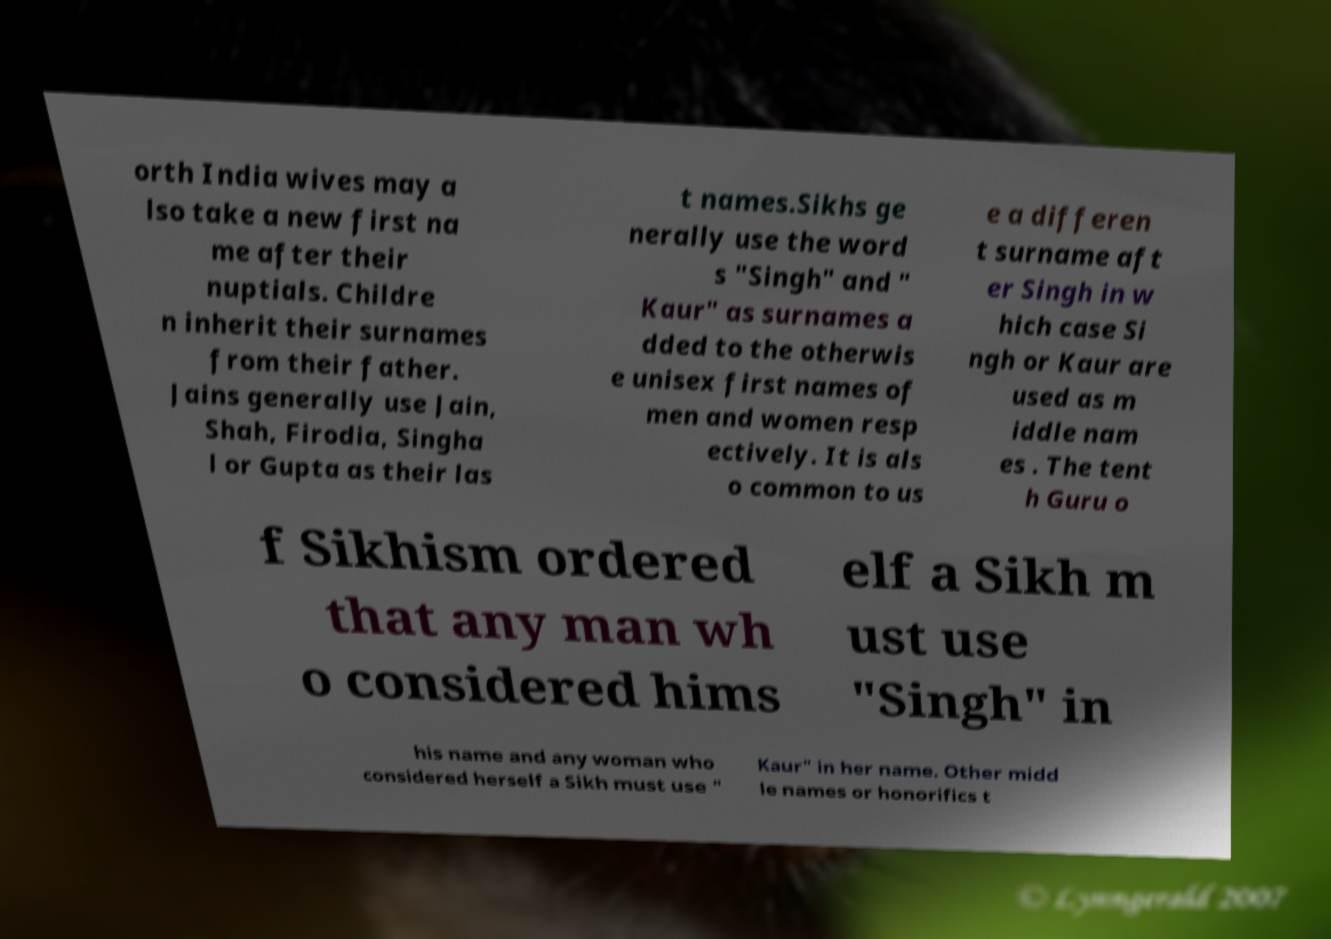Could you assist in decoding the text presented in this image and type it out clearly? orth India wives may a lso take a new first na me after their nuptials. Childre n inherit their surnames from their father. Jains generally use Jain, Shah, Firodia, Singha l or Gupta as their las t names.Sikhs ge nerally use the word s "Singh" and " Kaur" as surnames a dded to the otherwis e unisex first names of men and women resp ectively. It is als o common to us e a differen t surname aft er Singh in w hich case Si ngh or Kaur are used as m iddle nam es . The tent h Guru o f Sikhism ordered that any man wh o considered hims elf a Sikh m ust use "Singh" in his name and any woman who considered herself a Sikh must use " Kaur" in her name. Other midd le names or honorifics t 